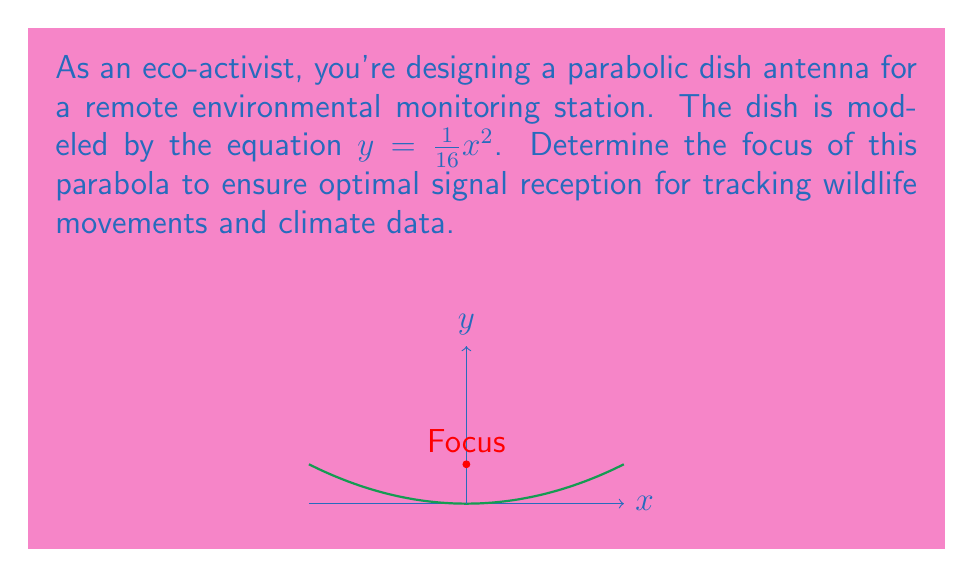Show me your answer to this math problem. To find the focus of the parabola, we'll follow these steps:

1) The general form of a parabola with a vertical axis of symmetry is:

   $y = a(x-h)^2 + k$

   where $(h,k)$ is the vertex and $a$ determines the direction and width.

2) Our parabola is given by $y = \frac{1}{16}x^2$, so $a = \frac{1}{16}$ and the vertex is at $(0,0)$.

3) For a parabola with a vertical axis of symmetry, the distance from the vertex to the focus is given by the formula:

   $p = \frac{1}{4a}$

4) Substituting our value of $a$:

   $p = \frac{1}{4(\frac{1}{16})} = \frac{1}{4} \cdot 16 = 4$

5) Since the parabola opens upward and the vertex is at $(0,0)$, the focus will be 4 units above the vertex on the y-axis.

Therefore, the coordinates of the focus are $(0,4)$.
Answer: $(0,4)$ 